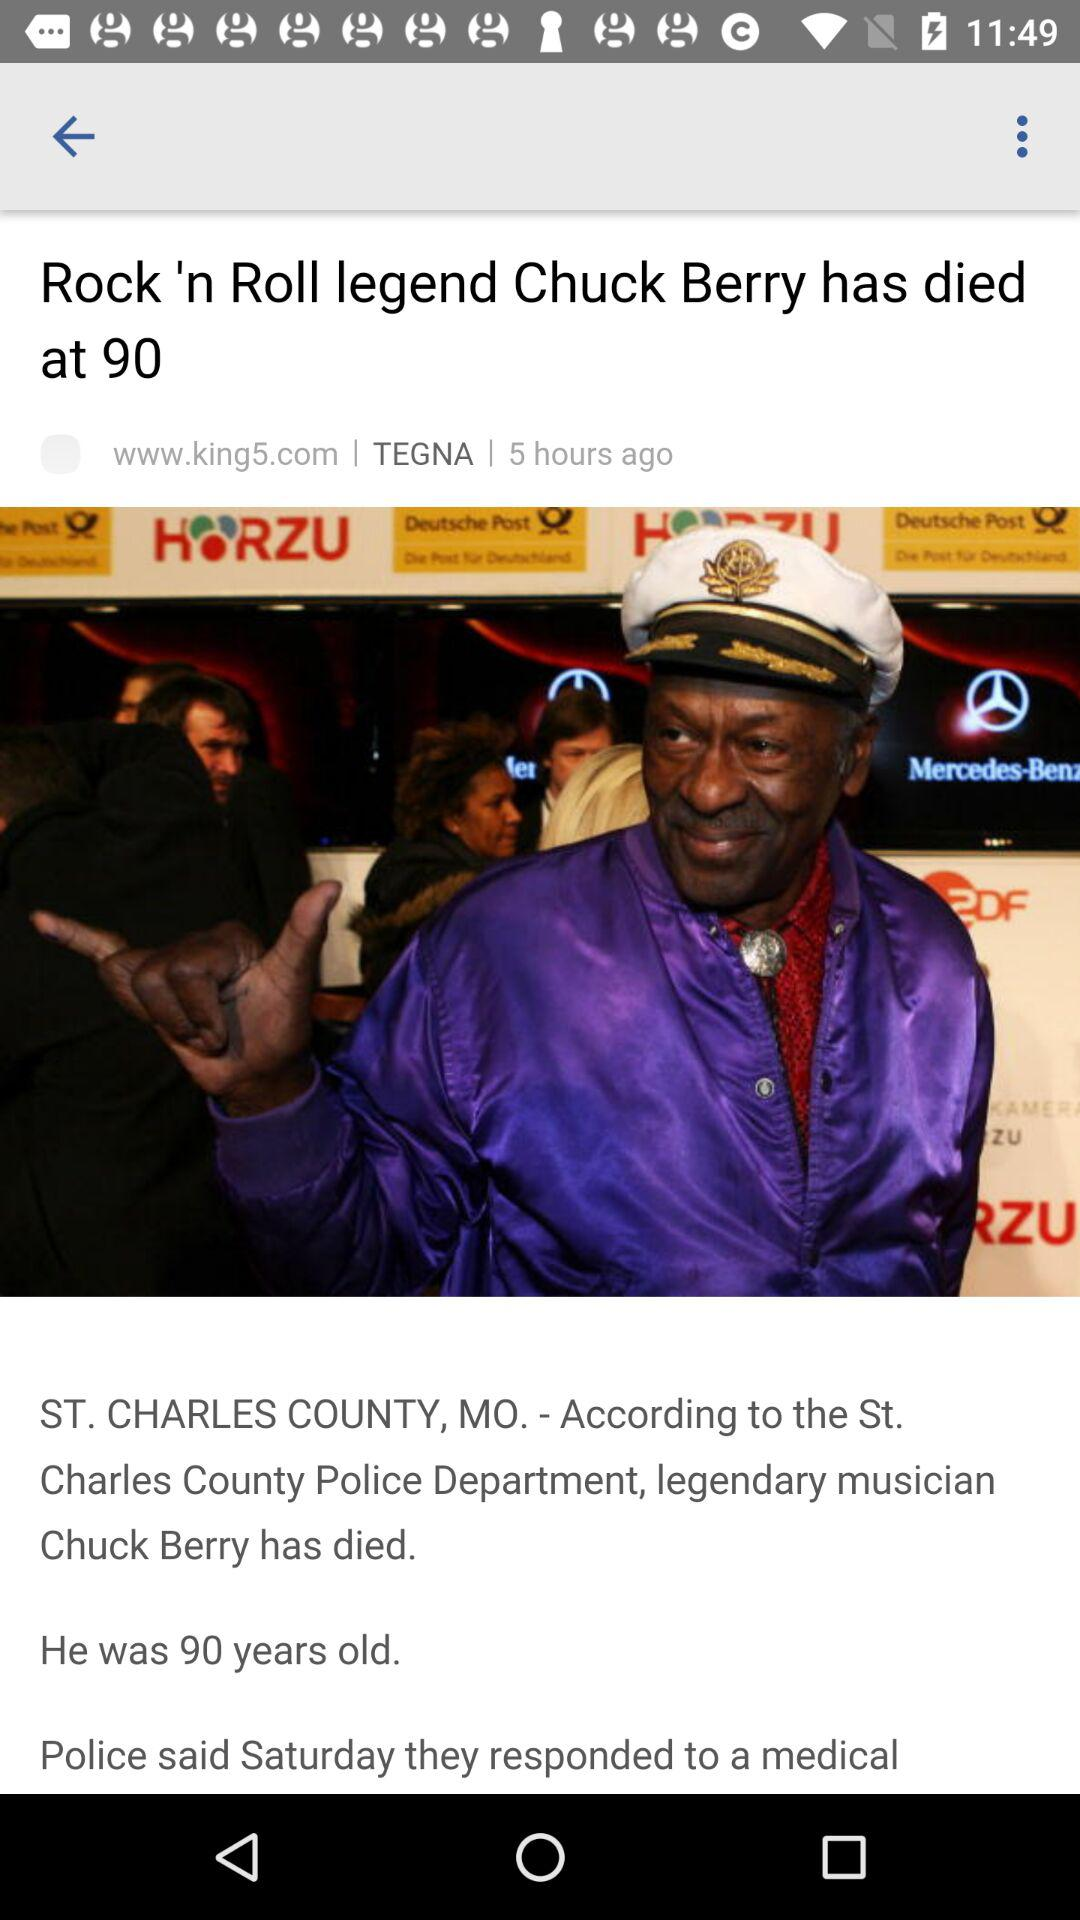What is the publication time of this article? The publication time is 5 hours ago. 